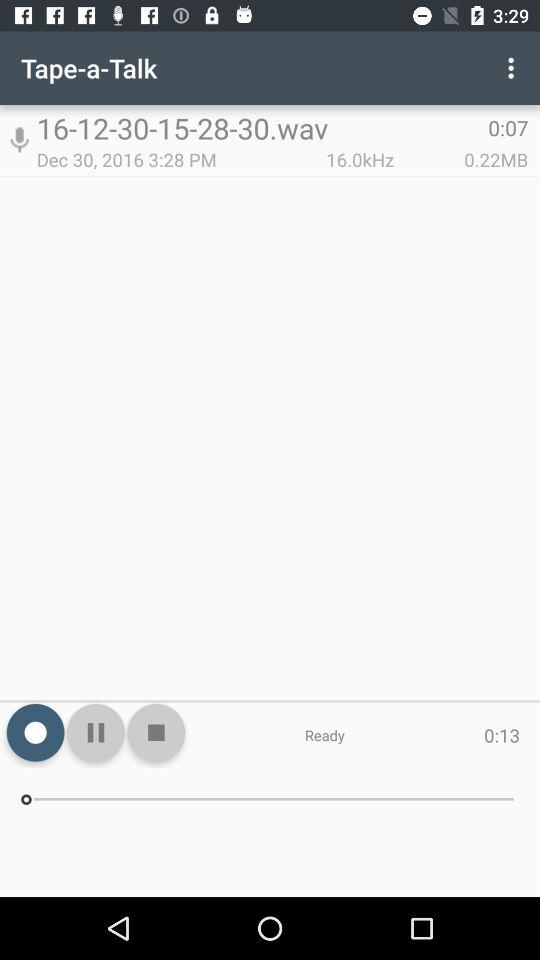On what date was the audio 16-12-30-15-28-30.wav created? The audio was created on December 30, 2016. 